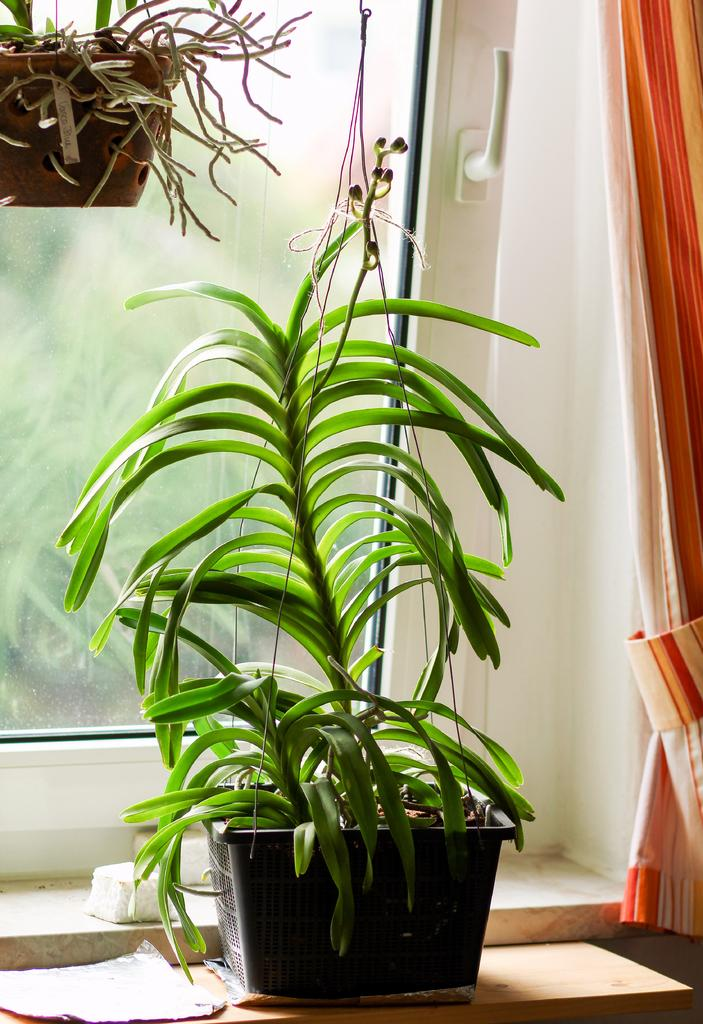What type of living organisms can be seen in the image? Plants can be seen in the image. What architectural feature is visible in the image? There is a window in the image. Is there any window treatment present in the image? Yes, there is a curtain associated with the window. What type of creature can be seen interacting with the plants in the image? There is no creature present in the image; it only features plants, a window, and a curtain. What time is it according to the clock in the image? There is no clock present in the image. 